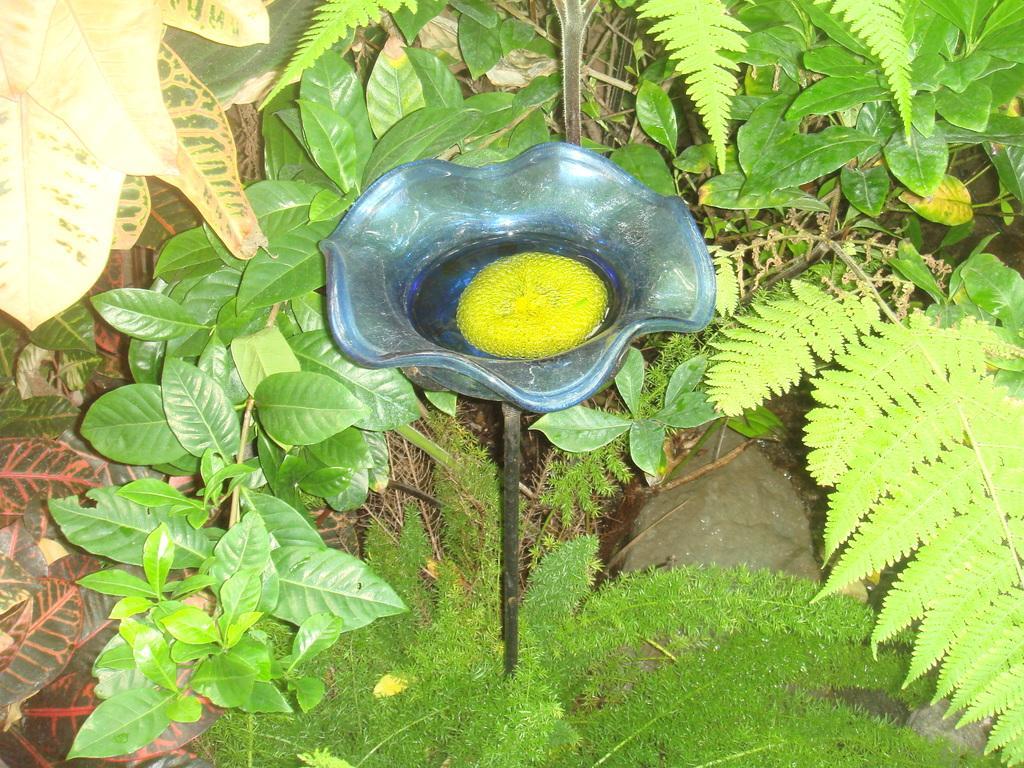How would you summarize this image in a sentence or two? In this picture I can see there are few plants and there are leaves here and there is a blue color object, there is some thing in it and it is attached to a pole. 